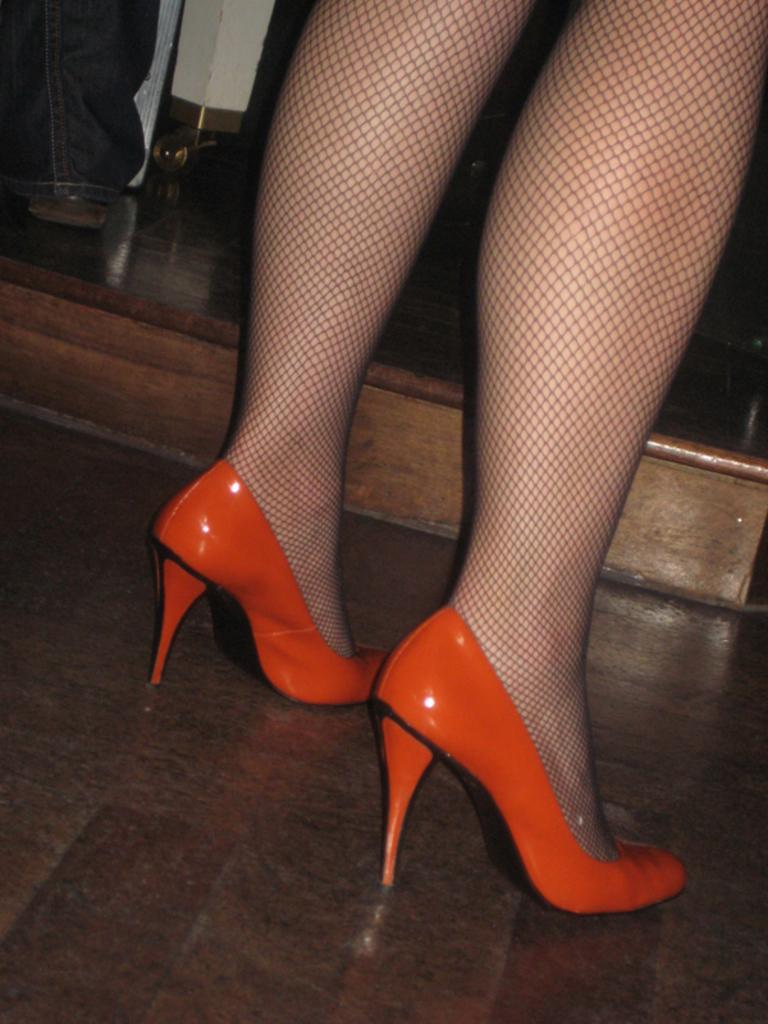How would you summarize this image in a sentence or two? In this image we can see the person's legs and that person is wearing the heels. In the background we can see the objects. 